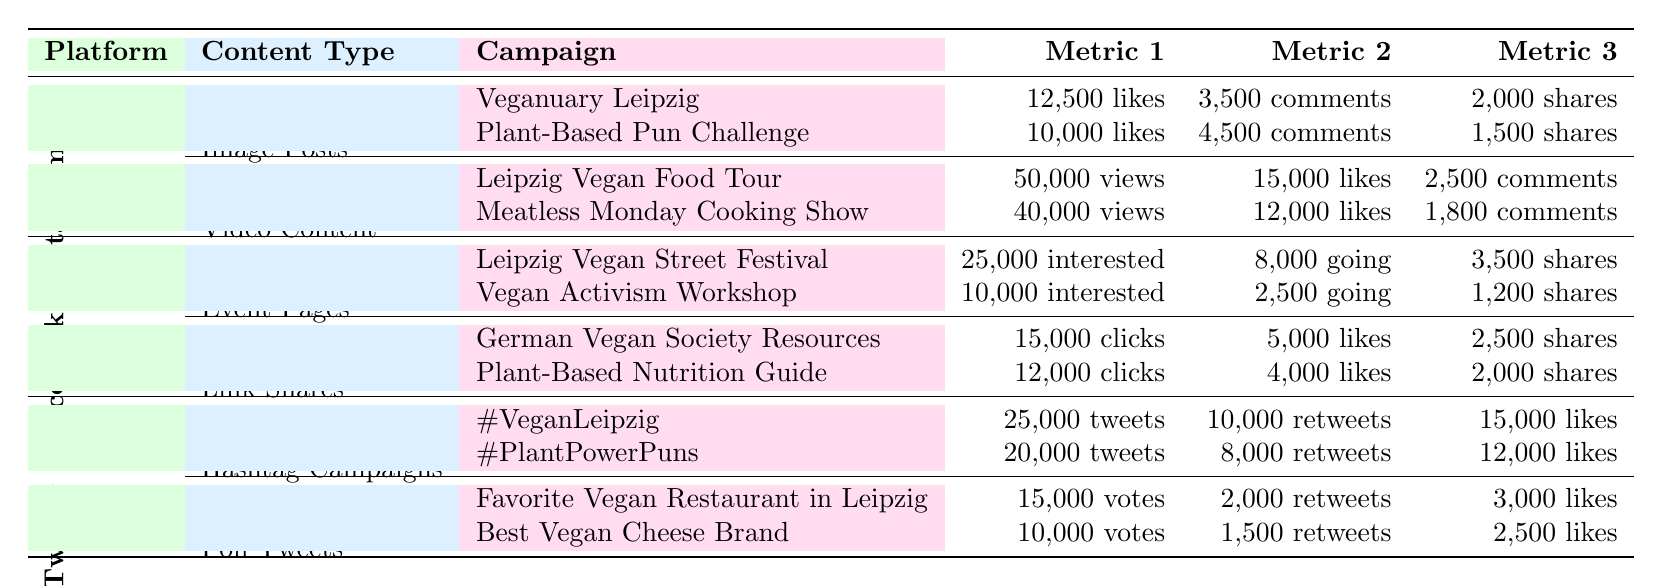What is the total engagement for Instagram campaigns? The total engagement for Instagram campaigns is directly listed in the table as 125,000.
Answer: 125,000 Which content type on Facebook received the most engagement? The content type with the highest engagement on Facebook is Event Pages, with 40,000 engagements listed.
Answer: Event Pages How many likes did the "Veganuary Leipzig" campaign receive on Instagram? The table specifies that the "Veganuary Leipzig" campaign received 12,500 likes, which is clearly shown in the Instagram section of the table.
Answer: 12,500 What is the engagement difference between Video Content and Image Posts on Instagram? Video Content engagement is 65,000 and Image Posts is 45,000. The difference is calculated as 65,000 - 45,000 = 20,000.
Answer: 20,000 Is the total engagement for Twitter campaigns greater than that for Facebook campaigns? Twitter total engagement is 75,000, while Facebook’s total engagement is 95,000. Since 75,000 is less than 95,000, the statement is false.
Answer: No Which campaign on Twitter had the highest number of likes? The "#VeganLeipzig" campaign had the highest likes at 15,000 among the Twitter campaigns listed.
Answer: #VeganLeipzig Calculate the average number of shares for the top campaigns on Facebook. The shares for the campaigns are 3,500 (Leipzig Vegan Street Festival) and 1,200 (Vegan Activism Workshop), summing to 4,700. Dividing this by 2 (the number of campaigns) gives an average of 2,350 shares.
Answer: 2,350 What is the total number of views for video campaigns on Instagram? The views for the two video campaigns, "Leipzig Vegan Food Tour" (50,000 views) and "Meatless Monday Cooking Show" (40,000 views), total to 50,000 + 40,000 = 90,000 views.
Answer: 90,000 Which platform had the highest total engagement? Comparing the total engagements: Instagram (125,000), Facebook (95,000), and Twitter (75,000), it is evident that Instagram has the highest engagement figure at 125,000.
Answer: Instagram Which content type on Twitter had the least engagement? Poll Tweets had an engagement of 25,000, which is less than Hashtag Campaigns (50,000), making Poll Tweets the least engaging on Twitter.
Answer: Poll Tweets What percentage of total engagement on Instagram comes from Video Content? Video Content has an engagement of 65,000 out of total 125,000 on Instagram. Thus, (65,000 / 125,000) * 100 = 52%.
Answer: 52% 